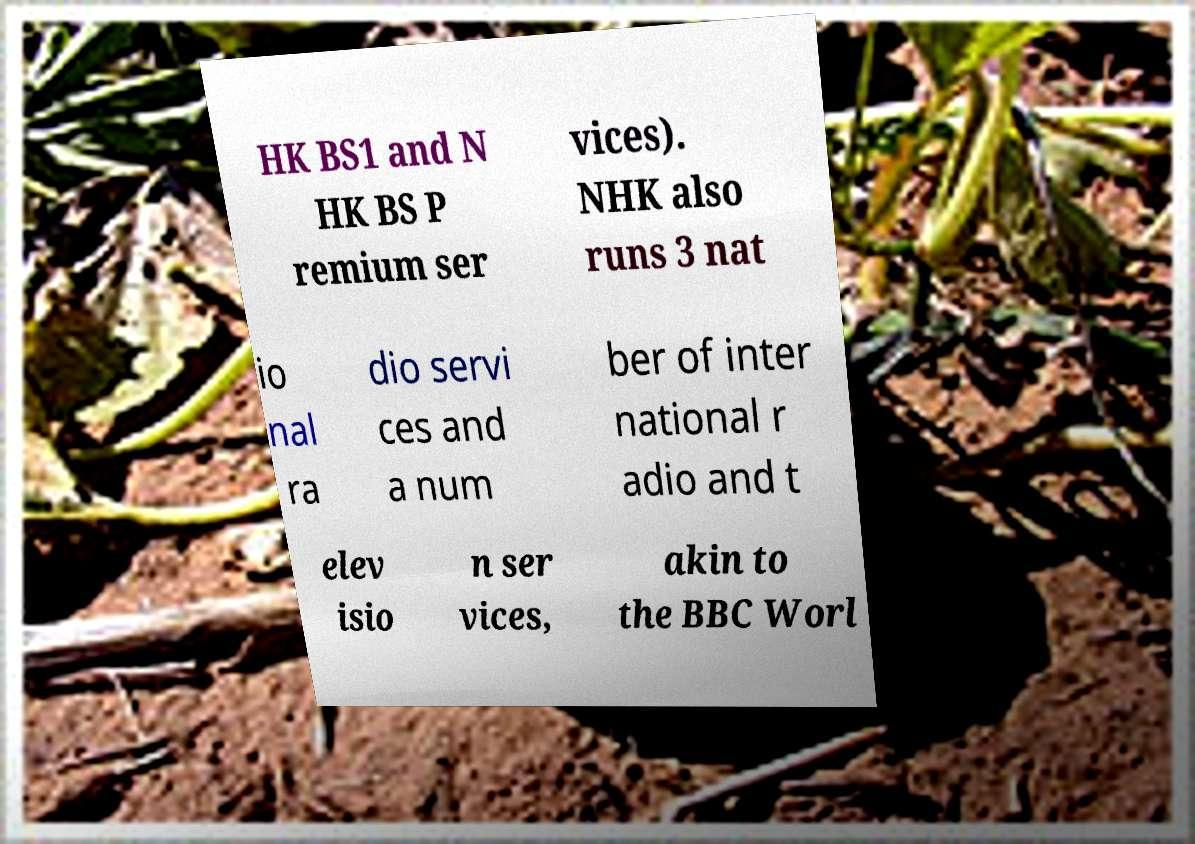Could you extract and type out the text from this image? HK BS1 and N HK BS P remium ser vices). NHK also runs 3 nat io nal ra dio servi ces and a num ber of inter national r adio and t elev isio n ser vices, akin to the BBC Worl 